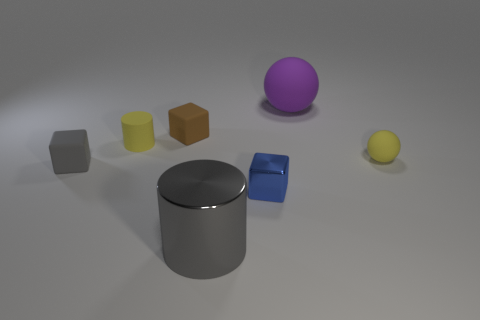Is the shape of the big object that is behind the small cylinder the same as the tiny rubber thing that is right of the small brown matte block?
Your response must be concise. Yes. What number of objects are tiny yellow rubber blocks or large gray metallic objects?
Provide a short and direct response. 1. Are any metallic cubes visible?
Provide a short and direct response. Yes. Do the tiny yellow thing on the right side of the small shiny cube and the tiny blue thing have the same material?
Offer a very short reply. No. Is there a purple rubber thing of the same shape as the small shiny object?
Provide a short and direct response. No. Are there the same number of brown blocks that are on the right side of the large gray metal cylinder and small brown rubber things?
Make the answer very short. No. There is a gray thing to the right of the brown block that is in front of the purple rubber sphere; what is it made of?
Provide a succinct answer. Metal. What is the shape of the tiny brown matte object?
Give a very brief answer. Cube. Are there an equal number of purple matte objects in front of the tiny cylinder and purple balls that are behind the big rubber thing?
Your answer should be very brief. Yes. There is a rubber sphere that is in front of the brown cube; does it have the same color as the big object in front of the large rubber object?
Provide a succinct answer. No. 